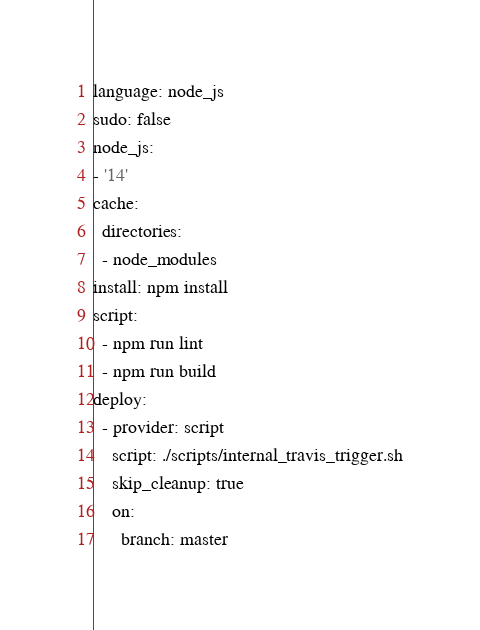<code> <loc_0><loc_0><loc_500><loc_500><_YAML_>language: node_js
sudo: false
node_js:
- '14'
cache:
  directories:
  - node_modules
install: npm install
script:
  - npm run lint
  - npm run build
deploy:
  - provider: script
    script: ./scripts/internal_travis_trigger.sh
    skip_cleanup: true
    on:
      branch: master
</code> 